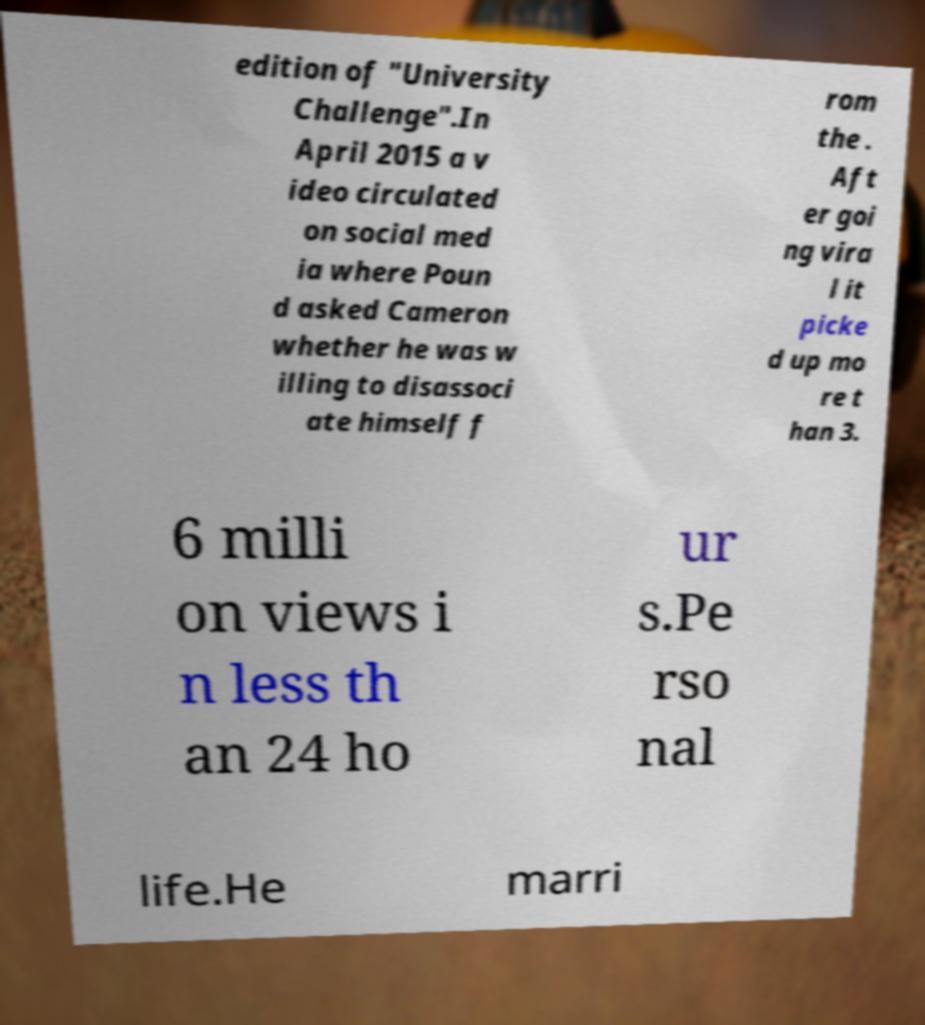Could you extract and type out the text from this image? edition of "University Challenge".In April 2015 a v ideo circulated on social med ia where Poun d asked Cameron whether he was w illing to disassoci ate himself f rom the . Aft er goi ng vira l it picke d up mo re t han 3. 6 milli on views i n less th an 24 ho ur s.Pe rso nal life.He marri 